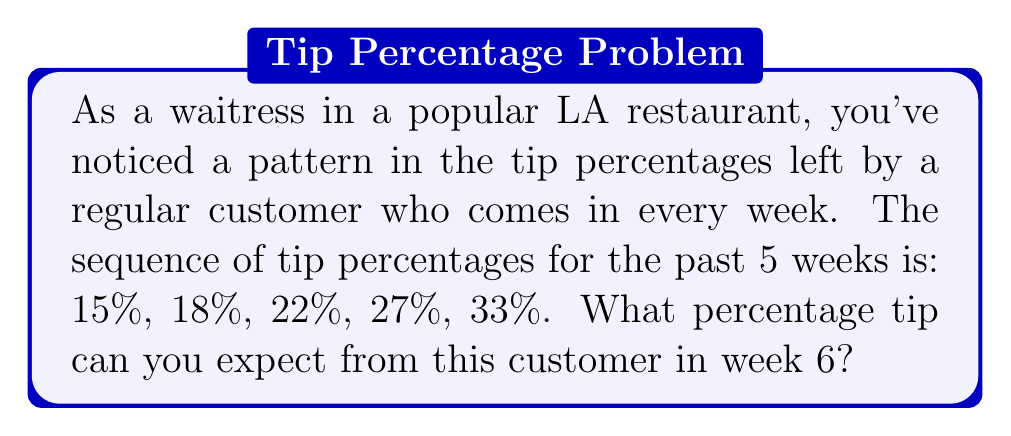Show me your answer to this math problem. Let's analyze the sequence step-by-step:

1) First, let's calculate the differences between consecutive terms:
   $18\% - 15\% = 3\%$
   $22\% - 18\% = 4\%$
   $27\% - 22\% = 5\%$
   $33\% - 27\% = 6\%$

2) We can observe that the differences are increasing by 1% each time:
   $3\%, 4\%, 5\%, 6\%$

3) Following this pattern, we can predict that the next difference will be 7%.

4) To find the next term in the original sequence, we add this difference to the last known term:
   $33\% + 7\% = 40\%$

Therefore, based on the observed pattern, you can expect a 40% tip from this customer in week 6.
Answer: 40% 